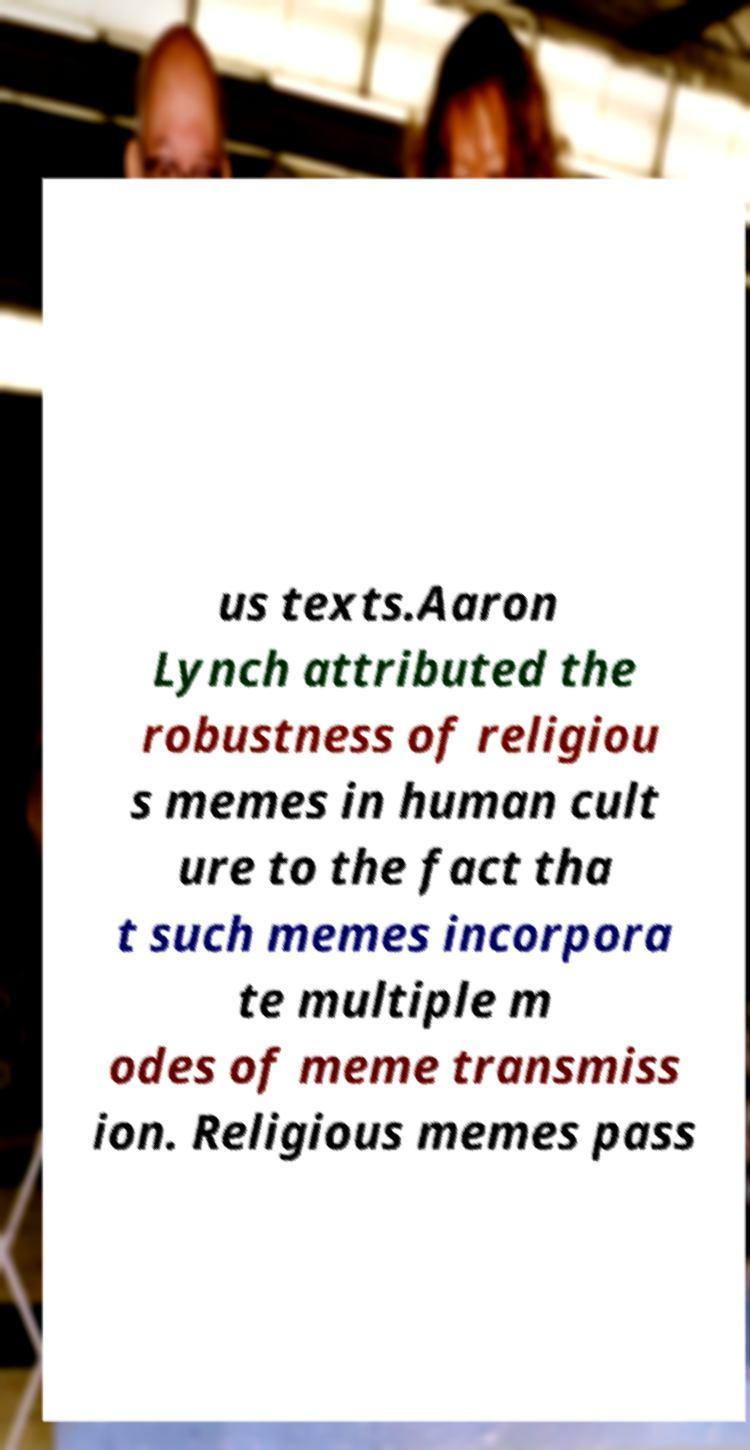Can you accurately transcribe the text from the provided image for me? us texts.Aaron Lynch attributed the robustness of religiou s memes in human cult ure to the fact tha t such memes incorpora te multiple m odes of meme transmiss ion. Religious memes pass 